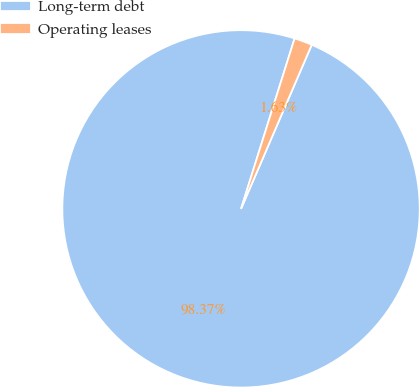<chart> <loc_0><loc_0><loc_500><loc_500><pie_chart><fcel>Long-term debt<fcel>Operating leases<nl><fcel>98.37%<fcel>1.63%<nl></chart> 